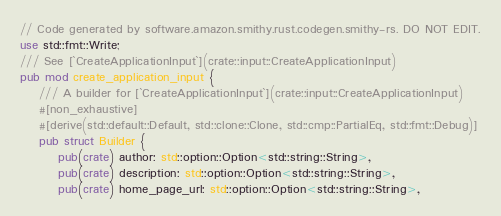Convert code to text. <code><loc_0><loc_0><loc_500><loc_500><_Rust_>// Code generated by software.amazon.smithy.rust.codegen.smithy-rs. DO NOT EDIT.
use std::fmt::Write;
/// See [`CreateApplicationInput`](crate::input::CreateApplicationInput)
pub mod create_application_input {
    /// A builder for [`CreateApplicationInput`](crate::input::CreateApplicationInput)
    #[non_exhaustive]
    #[derive(std::default::Default, std::clone::Clone, std::cmp::PartialEq, std::fmt::Debug)]
    pub struct Builder {
        pub(crate) author: std::option::Option<std::string::String>,
        pub(crate) description: std::option::Option<std::string::String>,
        pub(crate) home_page_url: std::option::Option<std::string::String>,</code> 